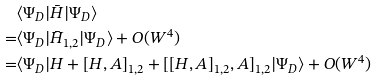Convert formula to latex. <formula><loc_0><loc_0><loc_500><loc_500>& \langle \Psi _ { D } | \bar { H } | \Psi _ { D } \rangle \\ = & \langle \Psi _ { D } | \bar { H } _ { 1 , 2 } | \Psi _ { D } \rangle + O ( W ^ { 4 } ) \\ = & \langle \Psi _ { D } | H + [ H , A ] _ { 1 , 2 } + [ [ H , A ] _ { 1 , 2 } , A ] _ { 1 , 2 } | \Psi _ { D } \rangle + O ( W ^ { 4 } )</formula> 